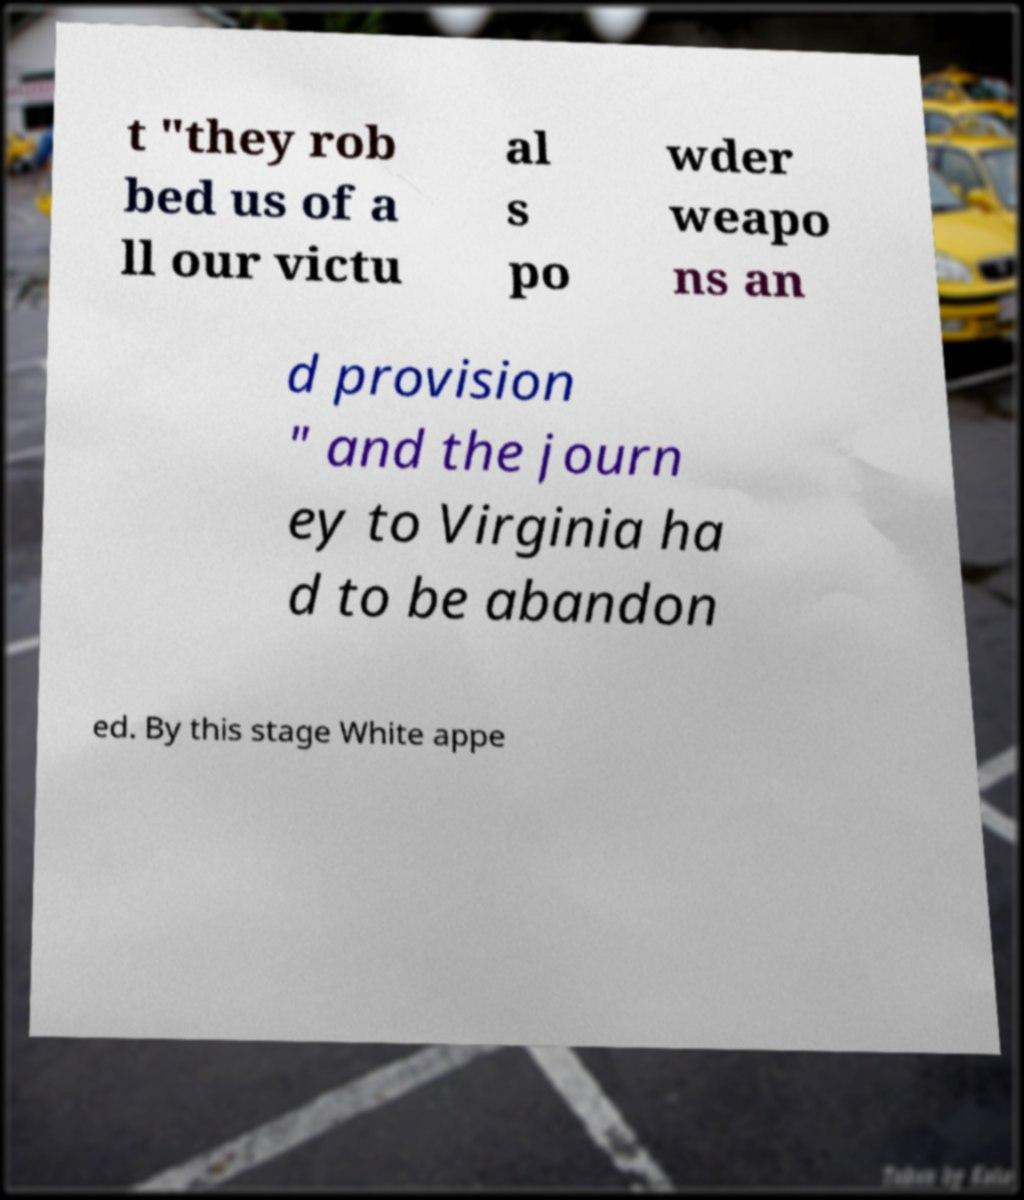Please read and relay the text visible in this image. What does it say? t "they rob bed us of a ll our victu al s po wder weapo ns an d provision " and the journ ey to Virginia ha d to be abandon ed. By this stage White appe 